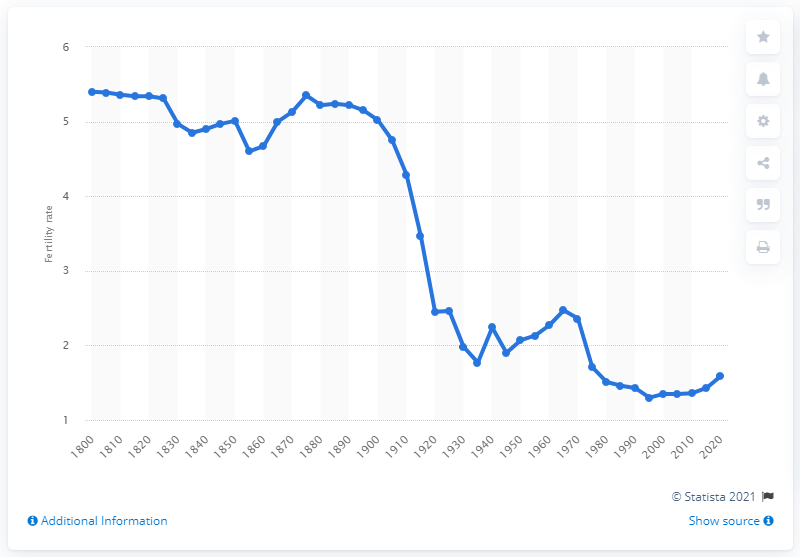List a handful of essential elements in this visual. In 1945, Germany's fertility rate was 1.9. In 1995, Germany's lowest fertility rate was 1.3. According to records from 1800, the average woman of childbearing age in Germany had 5.4 children. Germany's fertility rate reached its lowest point in 1855. 